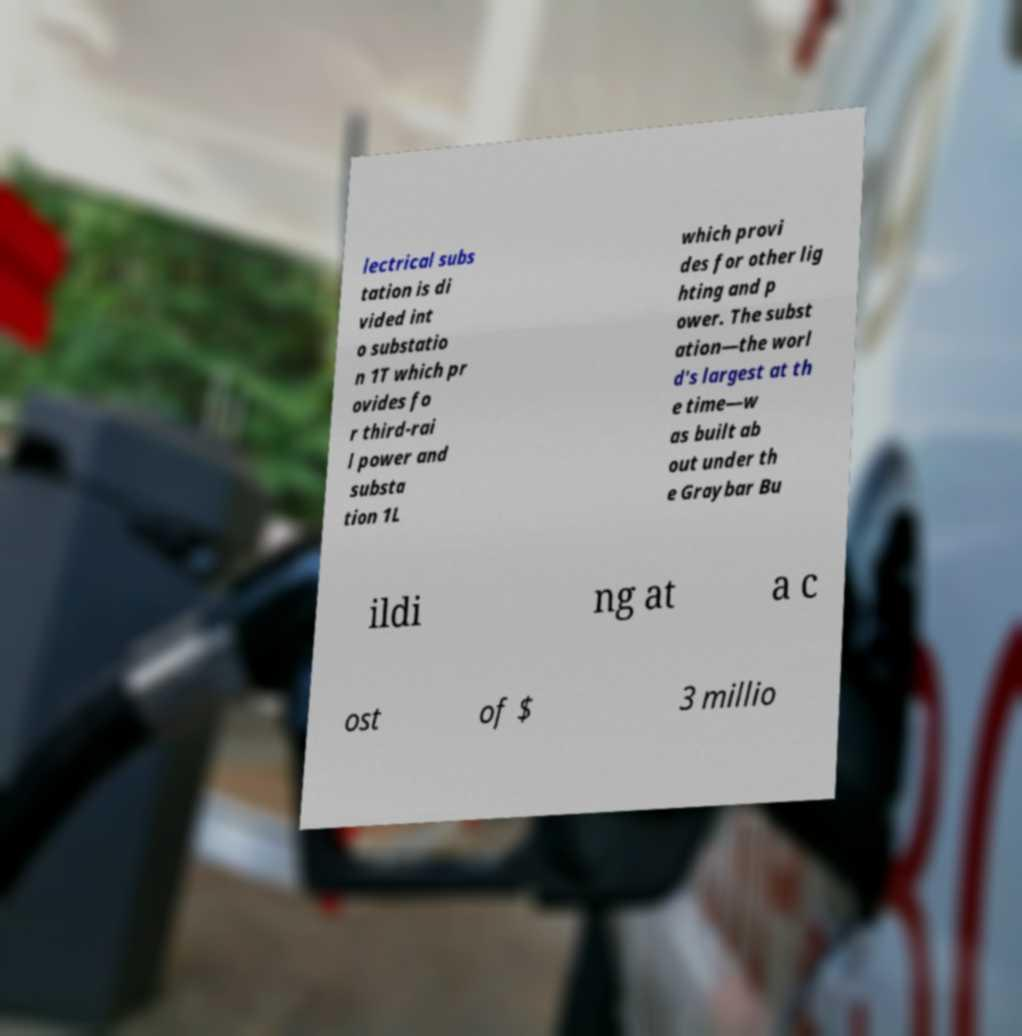There's text embedded in this image that I need extracted. Can you transcribe it verbatim? lectrical subs tation is di vided int o substatio n 1T which pr ovides fo r third-rai l power and substa tion 1L which provi des for other lig hting and p ower. The subst ation—the worl d's largest at th e time—w as built ab out under th e Graybar Bu ildi ng at a c ost of $ 3 millio 